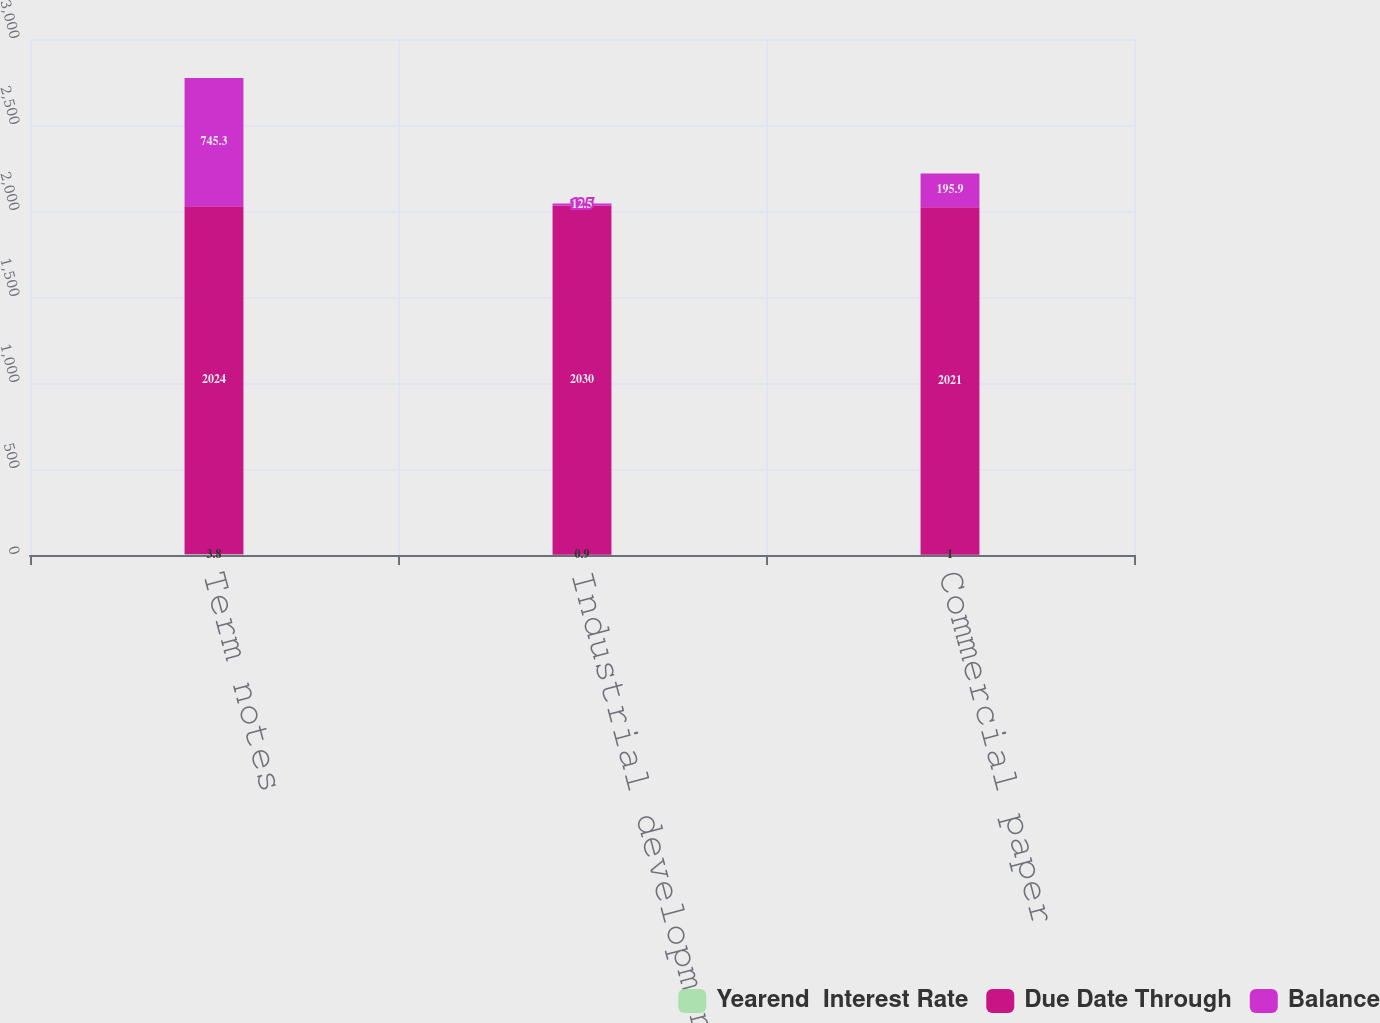Convert chart. <chart><loc_0><loc_0><loc_500><loc_500><stacked_bar_chart><ecel><fcel>Term notes<fcel>Industrial development bonds<fcel>Commercial paper<nl><fcel>Yearend  Interest Rate<fcel>3.8<fcel>0.9<fcel>1<nl><fcel>Due Date Through<fcel>2024<fcel>2030<fcel>2021<nl><fcel>Balance<fcel>745.3<fcel>12.5<fcel>195.9<nl></chart> 